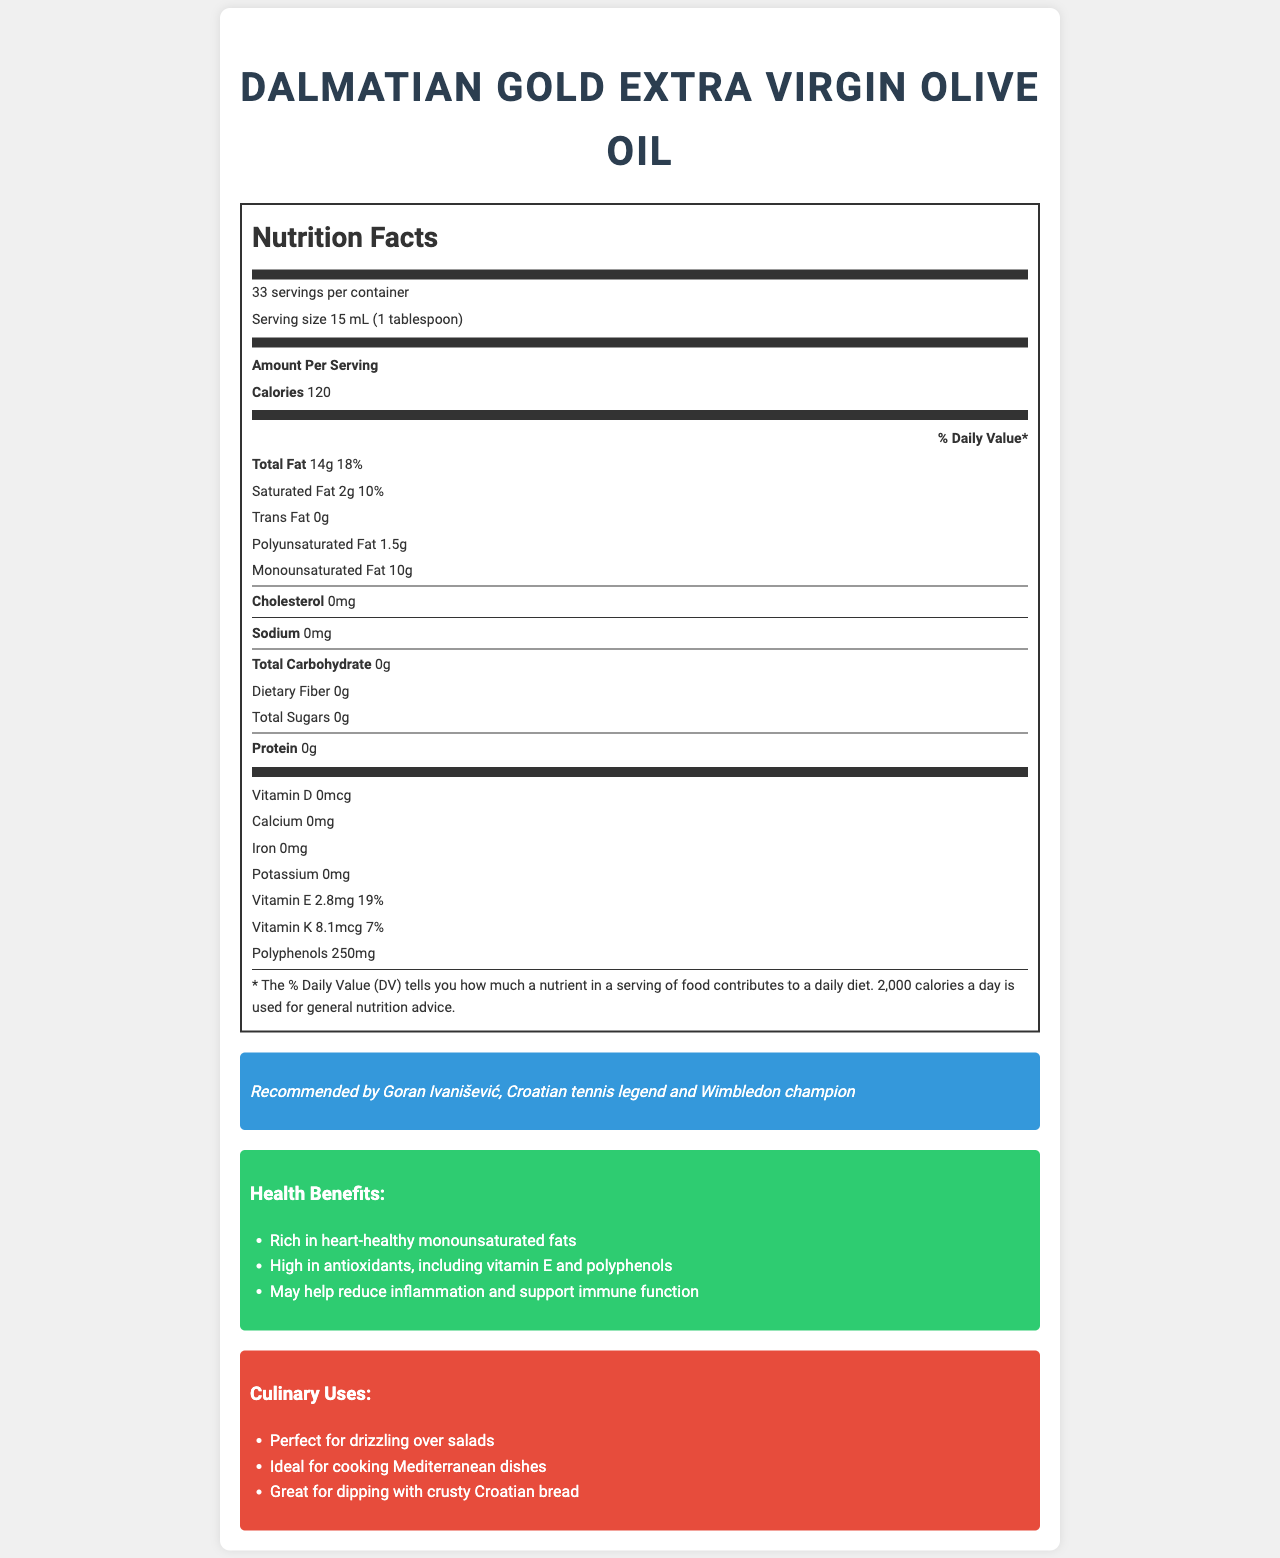what is the serving size of Dalmatian Gold Extra Virgin Olive Oil? The serving size is stated as "15 mL (1 tablespoon)" in the document.
Answer: 15 mL (1 tablespoon) how many calories are there per serving of the olive oil? The document specifies that there are 120 calories per serving.
Answer: 120 what percentage of the daily value of total fat is in one serving? The document indicates one serving contains 18% of the daily value for total fat.
Answer: 18% how much saturated fat does one serving of the olive oil contain? According to the document, one serving contains 2 grams of saturated fat.
Answer: 2g how much vitamin E is in a serving of the olive oil? The document states that there is 2.8 mg of Vitamin E per serving.
Answer: 2.8mg which of the following nutrients is NOT present in Dalmatian Gold Extra Virgin Olive Oil? A. Sodium B. Dietary Fiber C. Protein D. All of the above The document lists 0mg of Sodium, 0g of Dietary Fiber, and 0g of Protein, indicating none of these nutrients are present.
Answer: D what are the primary health benefits of this olive oil? The document outlines these health benefits explicitly in a section titled "Health Benefits".
Answer: Rich in heart-healthy monounsaturated fats, high in antioxidants, including vitamin E and polyphenols, may help reduce inflammation and support immune function where is this olive oil produced? A. Istria, Croatia B. Dalmatia, Croatia C. Tuscany, Italy The document mentions the olive oil's origin as Istria, Croatia.
Answer: A does this olive oil contain cholesterol? The document clearly shows "0mg" of cholesterol.
Answer: No summarize the key points of this Nutrition Facts label and additional details provided about the Dalmatian Gold Extra Virgin Olive Oil. This summary encapsulates the origin, nutritional breakdown, key health benefits, endorsements, and culinary uses listed in the document.
Answer: Dalmatian Gold Extra Virgin Olive Oil from Istria, Croatia, has 120 calories per serving, with 14g of total fat, including 2g of saturated fat. It contains heart-healthy monounsaturated fats and antioxidants like vitamin E (2.8mg) and polyphenols (250mg). The product does not contain cholesterol, sodium, carbohydrates, or protein. The oil is PDO certified, endorsed by Goran Ivanišević, and offers health benefits like reducing inflammation. It is ideal for Mediterranean dishes and best stored in a cool, dark place. what caution should be taken while storing this olive oil? The document advises on storage conditions to maintain the quality of the olive oil.
Answer: Store in a cool, dark place. Best consumed within 18 months of harvest date. when was the olive oil harvested? The harvest date is clearly stated as October 2022 in the document.
Answer: October 2022 what type of olives are used to produce Dalmatian Gold Extra Virgin Olive Oil? The document lists these specific olive varieties used.
Answer: Buža, Istarska bjelica, Leccino which Croatian tennis player recommends this olive oil? The document mentions the endorsement by Goran Ivanišević, citing him as a Wimbledon champion and Croatian tennis legend.
Answer: Goran Ivanišević can we determine the price of this olive oil from the document? The document does not provide any details regarding the price of the olive oil.
Answer: Not enough information 